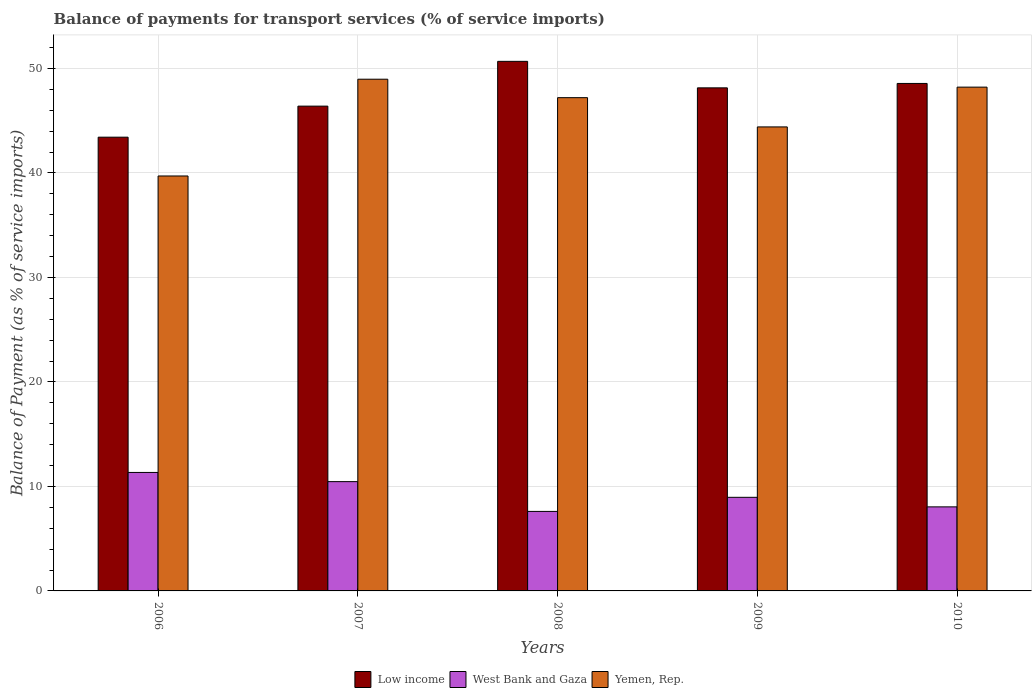How many groups of bars are there?
Make the answer very short. 5. Are the number of bars per tick equal to the number of legend labels?
Give a very brief answer. Yes. Are the number of bars on each tick of the X-axis equal?
Offer a very short reply. Yes. How many bars are there on the 3rd tick from the right?
Ensure brevity in your answer.  3. What is the balance of payments for transport services in Yemen, Rep. in 2008?
Keep it short and to the point. 47.21. Across all years, what is the maximum balance of payments for transport services in Yemen, Rep.?
Your answer should be very brief. 48.97. Across all years, what is the minimum balance of payments for transport services in West Bank and Gaza?
Offer a very short reply. 7.61. In which year was the balance of payments for transport services in West Bank and Gaza maximum?
Offer a terse response. 2006. What is the total balance of payments for transport services in Low income in the graph?
Make the answer very short. 237.21. What is the difference between the balance of payments for transport services in Low income in 2008 and that in 2010?
Offer a terse response. 2.11. What is the difference between the balance of payments for transport services in West Bank and Gaza in 2009 and the balance of payments for transport services in Yemen, Rep. in 2006?
Give a very brief answer. -30.75. What is the average balance of payments for transport services in Yemen, Rep. per year?
Make the answer very short. 45.7. In the year 2007, what is the difference between the balance of payments for transport services in Low income and balance of payments for transport services in West Bank and Gaza?
Offer a terse response. 35.94. What is the ratio of the balance of payments for transport services in Low income in 2008 to that in 2010?
Make the answer very short. 1.04. What is the difference between the highest and the second highest balance of payments for transport services in Yemen, Rep.?
Ensure brevity in your answer.  0.76. What is the difference between the highest and the lowest balance of payments for transport services in Low income?
Your answer should be compact. 7.26. What does the 1st bar from the left in 2006 represents?
Your response must be concise. Low income. What does the 3rd bar from the right in 2008 represents?
Provide a succinct answer. Low income. Are all the bars in the graph horizontal?
Give a very brief answer. No. How many years are there in the graph?
Give a very brief answer. 5. What is the difference between two consecutive major ticks on the Y-axis?
Offer a very short reply. 10. Does the graph contain any zero values?
Make the answer very short. No. Does the graph contain grids?
Offer a terse response. Yes. What is the title of the graph?
Ensure brevity in your answer.  Balance of payments for transport services (% of service imports). What is the label or title of the Y-axis?
Give a very brief answer. Balance of Payment (as % of service imports). What is the Balance of Payment (as % of service imports) of Low income in 2006?
Your answer should be very brief. 43.42. What is the Balance of Payment (as % of service imports) in West Bank and Gaza in 2006?
Keep it short and to the point. 11.34. What is the Balance of Payment (as % of service imports) in Yemen, Rep. in 2006?
Offer a very short reply. 39.71. What is the Balance of Payment (as % of service imports) of Low income in 2007?
Your answer should be very brief. 46.39. What is the Balance of Payment (as % of service imports) in West Bank and Gaza in 2007?
Give a very brief answer. 10.46. What is the Balance of Payment (as % of service imports) in Yemen, Rep. in 2007?
Make the answer very short. 48.97. What is the Balance of Payment (as % of service imports) of Low income in 2008?
Your answer should be very brief. 50.68. What is the Balance of Payment (as % of service imports) of West Bank and Gaza in 2008?
Offer a terse response. 7.61. What is the Balance of Payment (as % of service imports) of Yemen, Rep. in 2008?
Provide a succinct answer. 47.21. What is the Balance of Payment (as % of service imports) in Low income in 2009?
Keep it short and to the point. 48.14. What is the Balance of Payment (as % of service imports) of West Bank and Gaza in 2009?
Give a very brief answer. 8.96. What is the Balance of Payment (as % of service imports) of Yemen, Rep. in 2009?
Make the answer very short. 44.41. What is the Balance of Payment (as % of service imports) of Low income in 2010?
Provide a succinct answer. 48.57. What is the Balance of Payment (as % of service imports) of West Bank and Gaza in 2010?
Provide a short and direct response. 8.04. What is the Balance of Payment (as % of service imports) of Yemen, Rep. in 2010?
Your answer should be very brief. 48.21. Across all years, what is the maximum Balance of Payment (as % of service imports) in Low income?
Provide a short and direct response. 50.68. Across all years, what is the maximum Balance of Payment (as % of service imports) of West Bank and Gaza?
Keep it short and to the point. 11.34. Across all years, what is the maximum Balance of Payment (as % of service imports) in Yemen, Rep.?
Make the answer very short. 48.97. Across all years, what is the minimum Balance of Payment (as % of service imports) of Low income?
Make the answer very short. 43.42. Across all years, what is the minimum Balance of Payment (as % of service imports) in West Bank and Gaza?
Your answer should be compact. 7.61. Across all years, what is the minimum Balance of Payment (as % of service imports) of Yemen, Rep.?
Make the answer very short. 39.71. What is the total Balance of Payment (as % of service imports) of Low income in the graph?
Your answer should be compact. 237.21. What is the total Balance of Payment (as % of service imports) of West Bank and Gaza in the graph?
Make the answer very short. 46.41. What is the total Balance of Payment (as % of service imports) of Yemen, Rep. in the graph?
Your response must be concise. 228.5. What is the difference between the Balance of Payment (as % of service imports) of Low income in 2006 and that in 2007?
Your response must be concise. -2.97. What is the difference between the Balance of Payment (as % of service imports) in West Bank and Gaza in 2006 and that in 2007?
Offer a terse response. 0.88. What is the difference between the Balance of Payment (as % of service imports) in Yemen, Rep. in 2006 and that in 2007?
Make the answer very short. -9.26. What is the difference between the Balance of Payment (as % of service imports) of Low income in 2006 and that in 2008?
Provide a short and direct response. -7.26. What is the difference between the Balance of Payment (as % of service imports) in West Bank and Gaza in 2006 and that in 2008?
Provide a succinct answer. 3.73. What is the difference between the Balance of Payment (as % of service imports) of Yemen, Rep. in 2006 and that in 2008?
Offer a very short reply. -7.5. What is the difference between the Balance of Payment (as % of service imports) in Low income in 2006 and that in 2009?
Offer a very short reply. -4.72. What is the difference between the Balance of Payment (as % of service imports) in West Bank and Gaza in 2006 and that in 2009?
Your response must be concise. 2.38. What is the difference between the Balance of Payment (as % of service imports) of Yemen, Rep. in 2006 and that in 2009?
Provide a succinct answer. -4.7. What is the difference between the Balance of Payment (as % of service imports) in Low income in 2006 and that in 2010?
Your answer should be very brief. -5.14. What is the difference between the Balance of Payment (as % of service imports) in West Bank and Gaza in 2006 and that in 2010?
Offer a terse response. 3.29. What is the difference between the Balance of Payment (as % of service imports) in Yemen, Rep. in 2006 and that in 2010?
Keep it short and to the point. -8.5. What is the difference between the Balance of Payment (as % of service imports) in Low income in 2007 and that in 2008?
Make the answer very short. -4.29. What is the difference between the Balance of Payment (as % of service imports) in West Bank and Gaza in 2007 and that in 2008?
Your response must be concise. 2.85. What is the difference between the Balance of Payment (as % of service imports) of Yemen, Rep. in 2007 and that in 2008?
Provide a succinct answer. 1.77. What is the difference between the Balance of Payment (as % of service imports) of Low income in 2007 and that in 2009?
Provide a short and direct response. -1.75. What is the difference between the Balance of Payment (as % of service imports) of West Bank and Gaza in 2007 and that in 2009?
Offer a very short reply. 1.5. What is the difference between the Balance of Payment (as % of service imports) in Yemen, Rep. in 2007 and that in 2009?
Offer a terse response. 4.57. What is the difference between the Balance of Payment (as % of service imports) of Low income in 2007 and that in 2010?
Offer a very short reply. -2.17. What is the difference between the Balance of Payment (as % of service imports) in West Bank and Gaza in 2007 and that in 2010?
Your answer should be compact. 2.41. What is the difference between the Balance of Payment (as % of service imports) in Yemen, Rep. in 2007 and that in 2010?
Your answer should be compact. 0.76. What is the difference between the Balance of Payment (as % of service imports) of Low income in 2008 and that in 2009?
Provide a succinct answer. 2.54. What is the difference between the Balance of Payment (as % of service imports) of West Bank and Gaza in 2008 and that in 2009?
Provide a short and direct response. -1.35. What is the difference between the Balance of Payment (as % of service imports) of Yemen, Rep. in 2008 and that in 2009?
Provide a short and direct response. 2.8. What is the difference between the Balance of Payment (as % of service imports) in Low income in 2008 and that in 2010?
Give a very brief answer. 2.11. What is the difference between the Balance of Payment (as % of service imports) in West Bank and Gaza in 2008 and that in 2010?
Your answer should be compact. -0.44. What is the difference between the Balance of Payment (as % of service imports) in Yemen, Rep. in 2008 and that in 2010?
Your answer should be compact. -1.01. What is the difference between the Balance of Payment (as % of service imports) of Low income in 2009 and that in 2010?
Your answer should be compact. -0.42. What is the difference between the Balance of Payment (as % of service imports) of West Bank and Gaza in 2009 and that in 2010?
Your response must be concise. 0.91. What is the difference between the Balance of Payment (as % of service imports) of Yemen, Rep. in 2009 and that in 2010?
Your answer should be compact. -3.81. What is the difference between the Balance of Payment (as % of service imports) of Low income in 2006 and the Balance of Payment (as % of service imports) of West Bank and Gaza in 2007?
Keep it short and to the point. 32.96. What is the difference between the Balance of Payment (as % of service imports) of Low income in 2006 and the Balance of Payment (as % of service imports) of Yemen, Rep. in 2007?
Keep it short and to the point. -5.55. What is the difference between the Balance of Payment (as % of service imports) of West Bank and Gaza in 2006 and the Balance of Payment (as % of service imports) of Yemen, Rep. in 2007?
Your answer should be very brief. -37.63. What is the difference between the Balance of Payment (as % of service imports) in Low income in 2006 and the Balance of Payment (as % of service imports) in West Bank and Gaza in 2008?
Make the answer very short. 35.81. What is the difference between the Balance of Payment (as % of service imports) in Low income in 2006 and the Balance of Payment (as % of service imports) in Yemen, Rep. in 2008?
Ensure brevity in your answer.  -3.78. What is the difference between the Balance of Payment (as % of service imports) of West Bank and Gaza in 2006 and the Balance of Payment (as % of service imports) of Yemen, Rep. in 2008?
Offer a very short reply. -35.87. What is the difference between the Balance of Payment (as % of service imports) in Low income in 2006 and the Balance of Payment (as % of service imports) in West Bank and Gaza in 2009?
Offer a very short reply. 34.47. What is the difference between the Balance of Payment (as % of service imports) in Low income in 2006 and the Balance of Payment (as % of service imports) in Yemen, Rep. in 2009?
Your answer should be very brief. -0.98. What is the difference between the Balance of Payment (as % of service imports) of West Bank and Gaza in 2006 and the Balance of Payment (as % of service imports) of Yemen, Rep. in 2009?
Offer a very short reply. -33.07. What is the difference between the Balance of Payment (as % of service imports) of Low income in 2006 and the Balance of Payment (as % of service imports) of West Bank and Gaza in 2010?
Ensure brevity in your answer.  35.38. What is the difference between the Balance of Payment (as % of service imports) in Low income in 2006 and the Balance of Payment (as % of service imports) in Yemen, Rep. in 2010?
Your answer should be very brief. -4.79. What is the difference between the Balance of Payment (as % of service imports) of West Bank and Gaza in 2006 and the Balance of Payment (as % of service imports) of Yemen, Rep. in 2010?
Ensure brevity in your answer.  -36.87. What is the difference between the Balance of Payment (as % of service imports) of Low income in 2007 and the Balance of Payment (as % of service imports) of West Bank and Gaza in 2008?
Ensure brevity in your answer.  38.79. What is the difference between the Balance of Payment (as % of service imports) of Low income in 2007 and the Balance of Payment (as % of service imports) of Yemen, Rep. in 2008?
Give a very brief answer. -0.81. What is the difference between the Balance of Payment (as % of service imports) in West Bank and Gaza in 2007 and the Balance of Payment (as % of service imports) in Yemen, Rep. in 2008?
Your answer should be compact. -36.75. What is the difference between the Balance of Payment (as % of service imports) of Low income in 2007 and the Balance of Payment (as % of service imports) of West Bank and Gaza in 2009?
Ensure brevity in your answer.  37.44. What is the difference between the Balance of Payment (as % of service imports) in Low income in 2007 and the Balance of Payment (as % of service imports) in Yemen, Rep. in 2009?
Provide a short and direct response. 1.99. What is the difference between the Balance of Payment (as % of service imports) of West Bank and Gaza in 2007 and the Balance of Payment (as % of service imports) of Yemen, Rep. in 2009?
Your answer should be very brief. -33.95. What is the difference between the Balance of Payment (as % of service imports) in Low income in 2007 and the Balance of Payment (as % of service imports) in West Bank and Gaza in 2010?
Offer a terse response. 38.35. What is the difference between the Balance of Payment (as % of service imports) of Low income in 2007 and the Balance of Payment (as % of service imports) of Yemen, Rep. in 2010?
Your answer should be compact. -1.82. What is the difference between the Balance of Payment (as % of service imports) in West Bank and Gaza in 2007 and the Balance of Payment (as % of service imports) in Yemen, Rep. in 2010?
Provide a succinct answer. -37.75. What is the difference between the Balance of Payment (as % of service imports) of Low income in 2008 and the Balance of Payment (as % of service imports) of West Bank and Gaza in 2009?
Your response must be concise. 41.72. What is the difference between the Balance of Payment (as % of service imports) in Low income in 2008 and the Balance of Payment (as % of service imports) in Yemen, Rep. in 2009?
Ensure brevity in your answer.  6.27. What is the difference between the Balance of Payment (as % of service imports) of West Bank and Gaza in 2008 and the Balance of Payment (as % of service imports) of Yemen, Rep. in 2009?
Make the answer very short. -36.8. What is the difference between the Balance of Payment (as % of service imports) of Low income in 2008 and the Balance of Payment (as % of service imports) of West Bank and Gaza in 2010?
Provide a short and direct response. 42.64. What is the difference between the Balance of Payment (as % of service imports) of Low income in 2008 and the Balance of Payment (as % of service imports) of Yemen, Rep. in 2010?
Keep it short and to the point. 2.47. What is the difference between the Balance of Payment (as % of service imports) of West Bank and Gaza in 2008 and the Balance of Payment (as % of service imports) of Yemen, Rep. in 2010?
Provide a short and direct response. -40.6. What is the difference between the Balance of Payment (as % of service imports) in Low income in 2009 and the Balance of Payment (as % of service imports) in West Bank and Gaza in 2010?
Offer a very short reply. 40.1. What is the difference between the Balance of Payment (as % of service imports) in Low income in 2009 and the Balance of Payment (as % of service imports) in Yemen, Rep. in 2010?
Give a very brief answer. -0.07. What is the difference between the Balance of Payment (as % of service imports) of West Bank and Gaza in 2009 and the Balance of Payment (as % of service imports) of Yemen, Rep. in 2010?
Make the answer very short. -39.25. What is the average Balance of Payment (as % of service imports) in Low income per year?
Give a very brief answer. 47.44. What is the average Balance of Payment (as % of service imports) of West Bank and Gaza per year?
Your response must be concise. 9.28. What is the average Balance of Payment (as % of service imports) of Yemen, Rep. per year?
Give a very brief answer. 45.7. In the year 2006, what is the difference between the Balance of Payment (as % of service imports) in Low income and Balance of Payment (as % of service imports) in West Bank and Gaza?
Your answer should be compact. 32.08. In the year 2006, what is the difference between the Balance of Payment (as % of service imports) of Low income and Balance of Payment (as % of service imports) of Yemen, Rep.?
Make the answer very short. 3.71. In the year 2006, what is the difference between the Balance of Payment (as % of service imports) of West Bank and Gaza and Balance of Payment (as % of service imports) of Yemen, Rep.?
Keep it short and to the point. -28.37. In the year 2007, what is the difference between the Balance of Payment (as % of service imports) of Low income and Balance of Payment (as % of service imports) of West Bank and Gaza?
Offer a terse response. 35.94. In the year 2007, what is the difference between the Balance of Payment (as % of service imports) of Low income and Balance of Payment (as % of service imports) of Yemen, Rep.?
Your answer should be compact. -2.58. In the year 2007, what is the difference between the Balance of Payment (as % of service imports) in West Bank and Gaza and Balance of Payment (as % of service imports) in Yemen, Rep.?
Make the answer very short. -38.51. In the year 2008, what is the difference between the Balance of Payment (as % of service imports) in Low income and Balance of Payment (as % of service imports) in West Bank and Gaza?
Give a very brief answer. 43.07. In the year 2008, what is the difference between the Balance of Payment (as % of service imports) of Low income and Balance of Payment (as % of service imports) of Yemen, Rep.?
Offer a very short reply. 3.47. In the year 2008, what is the difference between the Balance of Payment (as % of service imports) of West Bank and Gaza and Balance of Payment (as % of service imports) of Yemen, Rep.?
Offer a very short reply. -39.6. In the year 2009, what is the difference between the Balance of Payment (as % of service imports) of Low income and Balance of Payment (as % of service imports) of West Bank and Gaza?
Your answer should be very brief. 39.19. In the year 2009, what is the difference between the Balance of Payment (as % of service imports) of Low income and Balance of Payment (as % of service imports) of Yemen, Rep.?
Your response must be concise. 3.74. In the year 2009, what is the difference between the Balance of Payment (as % of service imports) in West Bank and Gaza and Balance of Payment (as % of service imports) in Yemen, Rep.?
Provide a short and direct response. -35.45. In the year 2010, what is the difference between the Balance of Payment (as % of service imports) of Low income and Balance of Payment (as % of service imports) of West Bank and Gaza?
Give a very brief answer. 40.52. In the year 2010, what is the difference between the Balance of Payment (as % of service imports) of Low income and Balance of Payment (as % of service imports) of Yemen, Rep.?
Offer a terse response. 0.35. In the year 2010, what is the difference between the Balance of Payment (as % of service imports) in West Bank and Gaza and Balance of Payment (as % of service imports) in Yemen, Rep.?
Offer a very short reply. -40.17. What is the ratio of the Balance of Payment (as % of service imports) in Low income in 2006 to that in 2007?
Offer a terse response. 0.94. What is the ratio of the Balance of Payment (as % of service imports) in West Bank and Gaza in 2006 to that in 2007?
Make the answer very short. 1.08. What is the ratio of the Balance of Payment (as % of service imports) in Yemen, Rep. in 2006 to that in 2007?
Provide a succinct answer. 0.81. What is the ratio of the Balance of Payment (as % of service imports) of Low income in 2006 to that in 2008?
Your answer should be compact. 0.86. What is the ratio of the Balance of Payment (as % of service imports) of West Bank and Gaza in 2006 to that in 2008?
Your answer should be very brief. 1.49. What is the ratio of the Balance of Payment (as % of service imports) in Yemen, Rep. in 2006 to that in 2008?
Ensure brevity in your answer.  0.84. What is the ratio of the Balance of Payment (as % of service imports) of Low income in 2006 to that in 2009?
Your response must be concise. 0.9. What is the ratio of the Balance of Payment (as % of service imports) of West Bank and Gaza in 2006 to that in 2009?
Offer a terse response. 1.27. What is the ratio of the Balance of Payment (as % of service imports) in Yemen, Rep. in 2006 to that in 2009?
Your answer should be very brief. 0.89. What is the ratio of the Balance of Payment (as % of service imports) in Low income in 2006 to that in 2010?
Your answer should be compact. 0.89. What is the ratio of the Balance of Payment (as % of service imports) in West Bank and Gaza in 2006 to that in 2010?
Offer a very short reply. 1.41. What is the ratio of the Balance of Payment (as % of service imports) of Yemen, Rep. in 2006 to that in 2010?
Give a very brief answer. 0.82. What is the ratio of the Balance of Payment (as % of service imports) in Low income in 2007 to that in 2008?
Provide a succinct answer. 0.92. What is the ratio of the Balance of Payment (as % of service imports) in West Bank and Gaza in 2007 to that in 2008?
Provide a short and direct response. 1.37. What is the ratio of the Balance of Payment (as % of service imports) in Yemen, Rep. in 2007 to that in 2008?
Your response must be concise. 1.04. What is the ratio of the Balance of Payment (as % of service imports) in Low income in 2007 to that in 2009?
Ensure brevity in your answer.  0.96. What is the ratio of the Balance of Payment (as % of service imports) in West Bank and Gaza in 2007 to that in 2009?
Provide a succinct answer. 1.17. What is the ratio of the Balance of Payment (as % of service imports) of Yemen, Rep. in 2007 to that in 2009?
Give a very brief answer. 1.1. What is the ratio of the Balance of Payment (as % of service imports) in Low income in 2007 to that in 2010?
Your answer should be very brief. 0.96. What is the ratio of the Balance of Payment (as % of service imports) in West Bank and Gaza in 2007 to that in 2010?
Keep it short and to the point. 1.3. What is the ratio of the Balance of Payment (as % of service imports) of Yemen, Rep. in 2007 to that in 2010?
Give a very brief answer. 1.02. What is the ratio of the Balance of Payment (as % of service imports) in Low income in 2008 to that in 2009?
Your answer should be very brief. 1.05. What is the ratio of the Balance of Payment (as % of service imports) in West Bank and Gaza in 2008 to that in 2009?
Keep it short and to the point. 0.85. What is the ratio of the Balance of Payment (as % of service imports) in Yemen, Rep. in 2008 to that in 2009?
Offer a very short reply. 1.06. What is the ratio of the Balance of Payment (as % of service imports) in Low income in 2008 to that in 2010?
Provide a short and direct response. 1.04. What is the ratio of the Balance of Payment (as % of service imports) in West Bank and Gaza in 2008 to that in 2010?
Keep it short and to the point. 0.95. What is the ratio of the Balance of Payment (as % of service imports) in Yemen, Rep. in 2008 to that in 2010?
Provide a short and direct response. 0.98. What is the ratio of the Balance of Payment (as % of service imports) in West Bank and Gaza in 2009 to that in 2010?
Ensure brevity in your answer.  1.11. What is the ratio of the Balance of Payment (as % of service imports) in Yemen, Rep. in 2009 to that in 2010?
Ensure brevity in your answer.  0.92. What is the difference between the highest and the second highest Balance of Payment (as % of service imports) of Low income?
Provide a succinct answer. 2.11. What is the difference between the highest and the second highest Balance of Payment (as % of service imports) of West Bank and Gaza?
Provide a succinct answer. 0.88. What is the difference between the highest and the second highest Balance of Payment (as % of service imports) in Yemen, Rep.?
Provide a succinct answer. 0.76. What is the difference between the highest and the lowest Balance of Payment (as % of service imports) in Low income?
Your answer should be compact. 7.26. What is the difference between the highest and the lowest Balance of Payment (as % of service imports) in West Bank and Gaza?
Make the answer very short. 3.73. What is the difference between the highest and the lowest Balance of Payment (as % of service imports) in Yemen, Rep.?
Provide a short and direct response. 9.26. 